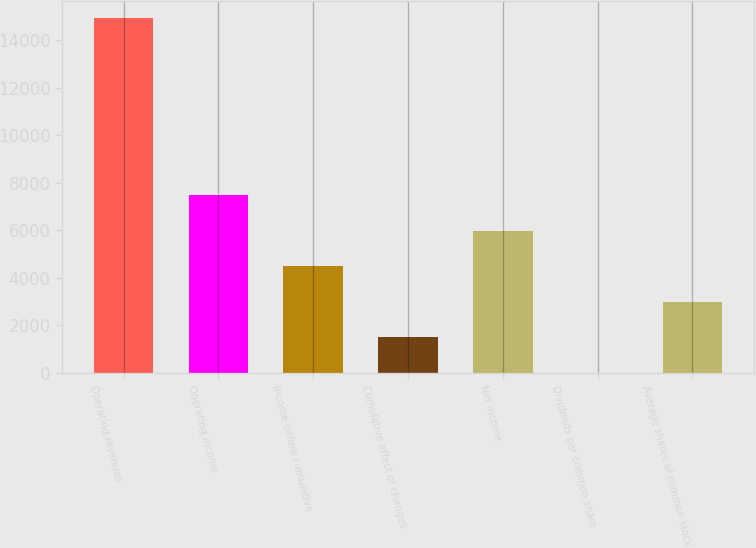<chart> <loc_0><loc_0><loc_500><loc_500><bar_chart><fcel>Operating revenues<fcel>Operating income<fcel>Income before cumulative<fcel>Cumulative effect of changes<fcel>Net income<fcel>Dividends per common share<fcel>Average shares of common stock<nl><fcel>14918<fcel>7459.46<fcel>4476.04<fcel>1492.62<fcel>5967.75<fcel>0.91<fcel>2984.33<nl></chart> 